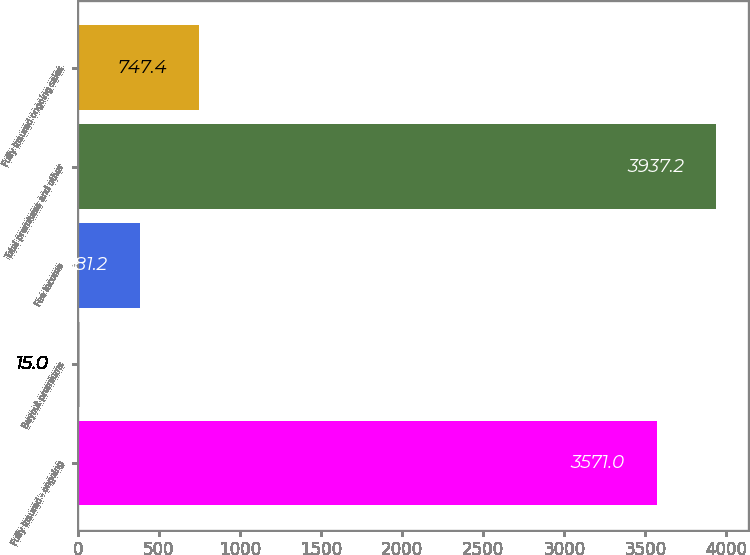Convert chart to OTSL. <chart><loc_0><loc_0><loc_500><loc_500><bar_chart><fcel>Fully insured - ongoing<fcel>Buyout premiums<fcel>Fee income<fcel>Total premiums and other<fcel>Fully insured ongoing sales<nl><fcel>3571<fcel>15<fcel>381.2<fcel>3937.2<fcel>747.4<nl></chart> 